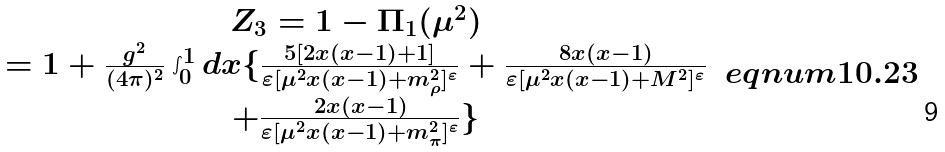<formula> <loc_0><loc_0><loc_500><loc_500>\begin{array} { c } Z _ { 3 } = 1 - \Pi _ { 1 } ( \mu ^ { 2 } ) \\ = 1 + \frac { g ^ { 2 } } { ( 4 \pi ) ^ { 2 } } \int _ { 0 } ^ { 1 } d x \{ \frac { 5 [ 2 x ( x - 1 ) + 1 ] } { \varepsilon [ \mu ^ { 2 } x ( x - 1 ) + m _ { \rho } ^ { 2 } ] ^ { \varepsilon } } + \frac { 8 x ( x - 1 ) } { \varepsilon [ \mu ^ { 2 } x ( x - 1 ) + M ^ { 2 } ] ^ { \varepsilon } } \\ + \frac { 2 x ( x - 1 ) } { \varepsilon [ \mu ^ { 2 } x ( x - 1 ) + m _ { \pi } ^ { 2 } ] ^ { \varepsilon } } \} \end{array} \ e q n u m { 1 0 . 2 3 }</formula> 